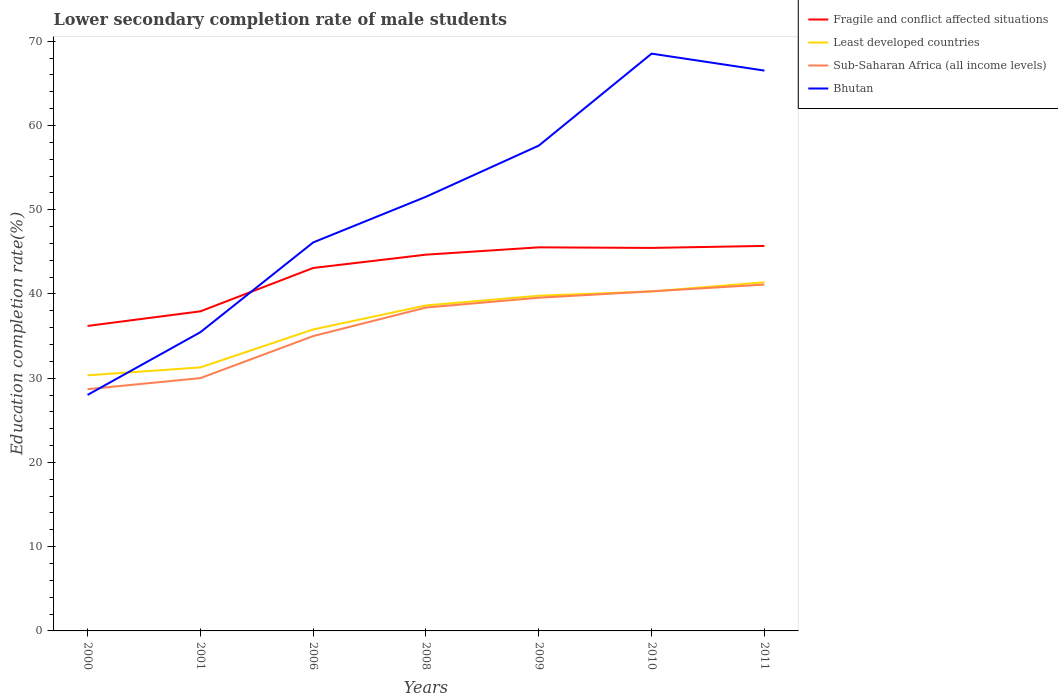Is the number of lines equal to the number of legend labels?
Give a very brief answer. Yes. Across all years, what is the maximum lower secondary completion rate of male students in Fragile and conflict affected situations?
Keep it short and to the point. 36.21. In which year was the lower secondary completion rate of male students in Bhutan maximum?
Provide a short and direct response. 2000. What is the total lower secondary completion rate of male students in Sub-Saharan Africa (all income levels) in the graph?
Provide a succinct answer. -2.72. What is the difference between the highest and the second highest lower secondary completion rate of male students in Bhutan?
Your answer should be very brief. 40.52. What is the difference between the highest and the lowest lower secondary completion rate of male students in Bhutan?
Offer a terse response. 4. Is the lower secondary completion rate of male students in Sub-Saharan Africa (all income levels) strictly greater than the lower secondary completion rate of male students in Fragile and conflict affected situations over the years?
Offer a terse response. Yes. How many lines are there?
Ensure brevity in your answer.  4. How many years are there in the graph?
Give a very brief answer. 7. Does the graph contain grids?
Make the answer very short. No. What is the title of the graph?
Your answer should be compact. Lower secondary completion rate of male students. What is the label or title of the Y-axis?
Offer a very short reply. Education completion rate(%). What is the Education completion rate(%) of Fragile and conflict affected situations in 2000?
Give a very brief answer. 36.21. What is the Education completion rate(%) in Least developed countries in 2000?
Provide a succinct answer. 30.35. What is the Education completion rate(%) of Sub-Saharan Africa (all income levels) in 2000?
Give a very brief answer. 28.7. What is the Education completion rate(%) in Bhutan in 2000?
Offer a terse response. 28.02. What is the Education completion rate(%) of Fragile and conflict affected situations in 2001?
Keep it short and to the point. 37.94. What is the Education completion rate(%) in Least developed countries in 2001?
Give a very brief answer. 31.28. What is the Education completion rate(%) of Sub-Saharan Africa (all income levels) in 2001?
Offer a very short reply. 30.01. What is the Education completion rate(%) of Bhutan in 2001?
Your answer should be compact. 35.46. What is the Education completion rate(%) of Fragile and conflict affected situations in 2006?
Give a very brief answer. 43.09. What is the Education completion rate(%) in Least developed countries in 2006?
Make the answer very short. 35.79. What is the Education completion rate(%) of Sub-Saharan Africa (all income levels) in 2006?
Your answer should be compact. 35. What is the Education completion rate(%) in Bhutan in 2006?
Offer a terse response. 46.12. What is the Education completion rate(%) of Fragile and conflict affected situations in 2008?
Your response must be concise. 44.67. What is the Education completion rate(%) in Least developed countries in 2008?
Make the answer very short. 38.64. What is the Education completion rate(%) in Sub-Saharan Africa (all income levels) in 2008?
Your response must be concise. 38.39. What is the Education completion rate(%) of Bhutan in 2008?
Provide a short and direct response. 51.54. What is the Education completion rate(%) in Fragile and conflict affected situations in 2009?
Offer a terse response. 45.54. What is the Education completion rate(%) of Least developed countries in 2009?
Give a very brief answer. 39.79. What is the Education completion rate(%) of Sub-Saharan Africa (all income levels) in 2009?
Ensure brevity in your answer.  39.55. What is the Education completion rate(%) in Bhutan in 2009?
Give a very brief answer. 57.62. What is the Education completion rate(%) of Fragile and conflict affected situations in 2010?
Keep it short and to the point. 45.47. What is the Education completion rate(%) in Least developed countries in 2010?
Provide a short and direct response. 40.3. What is the Education completion rate(%) of Sub-Saharan Africa (all income levels) in 2010?
Your answer should be compact. 40.32. What is the Education completion rate(%) of Bhutan in 2010?
Provide a short and direct response. 68.53. What is the Education completion rate(%) in Fragile and conflict affected situations in 2011?
Keep it short and to the point. 45.71. What is the Education completion rate(%) of Least developed countries in 2011?
Offer a terse response. 41.39. What is the Education completion rate(%) of Sub-Saharan Africa (all income levels) in 2011?
Provide a short and direct response. 41.12. What is the Education completion rate(%) of Bhutan in 2011?
Offer a very short reply. 66.52. Across all years, what is the maximum Education completion rate(%) of Fragile and conflict affected situations?
Provide a short and direct response. 45.71. Across all years, what is the maximum Education completion rate(%) of Least developed countries?
Your answer should be compact. 41.39. Across all years, what is the maximum Education completion rate(%) of Sub-Saharan Africa (all income levels)?
Provide a short and direct response. 41.12. Across all years, what is the maximum Education completion rate(%) in Bhutan?
Keep it short and to the point. 68.53. Across all years, what is the minimum Education completion rate(%) in Fragile and conflict affected situations?
Give a very brief answer. 36.21. Across all years, what is the minimum Education completion rate(%) of Least developed countries?
Your response must be concise. 30.35. Across all years, what is the minimum Education completion rate(%) of Sub-Saharan Africa (all income levels)?
Offer a very short reply. 28.7. Across all years, what is the minimum Education completion rate(%) of Bhutan?
Offer a terse response. 28.02. What is the total Education completion rate(%) in Fragile and conflict affected situations in the graph?
Ensure brevity in your answer.  298.62. What is the total Education completion rate(%) of Least developed countries in the graph?
Give a very brief answer. 257.55. What is the total Education completion rate(%) of Sub-Saharan Africa (all income levels) in the graph?
Offer a very short reply. 253.1. What is the total Education completion rate(%) of Bhutan in the graph?
Give a very brief answer. 353.82. What is the difference between the Education completion rate(%) of Fragile and conflict affected situations in 2000 and that in 2001?
Give a very brief answer. -1.73. What is the difference between the Education completion rate(%) of Least developed countries in 2000 and that in 2001?
Ensure brevity in your answer.  -0.94. What is the difference between the Education completion rate(%) in Sub-Saharan Africa (all income levels) in 2000 and that in 2001?
Offer a terse response. -1.31. What is the difference between the Education completion rate(%) of Bhutan in 2000 and that in 2001?
Offer a terse response. -7.45. What is the difference between the Education completion rate(%) of Fragile and conflict affected situations in 2000 and that in 2006?
Provide a succinct answer. -6.88. What is the difference between the Education completion rate(%) of Least developed countries in 2000 and that in 2006?
Ensure brevity in your answer.  -5.44. What is the difference between the Education completion rate(%) of Sub-Saharan Africa (all income levels) in 2000 and that in 2006?
Ensure brevity in your answer.  -6.3. What is the difference between the Education completion rate(%) of Bhutan in 2000 and that in 2006?
Give a very brief answer. -18.1. What is the difference between the Education completion rate(%) of Fragile and conflict affected situations in 2000 and that in 2008?
Make the answer very short. -8.46. What is the difference between the Education completion rate(%) of Least developed countries in 2000 and that in 2008?
Offer a very short reply. -8.3. What is the difference between the Education completion rate(%) of Sub-Saharan Africa (all income levels) in 2000 and that in 2008?
Make the answer very short. -9.69. What is the difference between the Education completion rate(%) of Bhutan in 2000 and that in 2008?
Provide a short and direct response. -23.53. What is the difference between the Education completion rate(%) in Fragile and conflict affected situations in 2000 and that in 2009?
Your answer should be very brief. -9.33. What is the difference between the Education completion rate(%) of Least developed countries in 2000 and that in 2009?
Your response must be concise. -9.45. What is the difference between the Education completion rate(%) in Sub-Saharan Africa (all income levels) in 2000 and that in 2009?
Keep it short and to the point. -10.85. What is the difference between the Education completion rate(%) in Bhutan in 2000 and that in 2009?
Offer a terse response. -29.6. What is the difference between the Education completion rate(%) in Fragile and conflict affected situations in 2000 and that in 2010?
Your answer should be compact. -9.26. What is the difference between the Education completion rate(%) of Least developed countries in 2000 and that in 2010?
Make the answer very short. -9.96. What is the difference between the Education completion rate(%) of Sub-Saharan Africa (all income levels) in 2000 and that in 2010?
Provide a short and direct response. -11.62. What is the difference between the Education completion rate(%) of Bhutan in 2000 and that in 2010?
Your answer should be compact. -40.52. What is the difference between the Education completion rate(%) in Fragile and conflict affected situations in 2000 and that in 2011?
Offer a very short reply. -9.5. What is the difference between the Education completion rate(%) of Least developed countries in 2000 and that in 2011?
Offer a terse response. -11.04. What is the difference between the Education completion rate(%) of Sub-Saharan Africa (all income levels) in 2000 and that in 2011?
Your response must be concise. -12.42. What is the difference between the Education completion rate(%) in Bhutan in 2000 and that in 2011?
Provide a succinct answer. -38.5. What is the difference between the Education completion rate(%) in Fragile and conflict affected situations in 2001 and that in 2006?
Your answer should be very brief. -5.15. What is the difference between the Education completion rate(%) of Least developed countries in 2001 and that in 2006?
Offer a very short reply. -4.51. What is the difference between the Education completion rate(%) of Sub-Saharan Africa (all income levels) in 2001 and that in 2006?
Provide a short and direct response. -4.99. What is the difference between the Education completion rate(%) in Bhutan in 2001 and that in 2006?
Your answer should be compact. -10.66. What is the difference between the Education completion rate(%) in Fragile and conflict affected situations in 2001 and that in 2008?
Your response must be concise. -6.73. What is the difference between the Education completion rate(%) of Least developed countries in 2001 and that in 2008?
Your response must be concise. -7.36. What is the difference between the Education completion rate(%) in Sub-Saharan Africa (all income levels) in 2001 and that in 2008?
Give a very brief answer. -8.38. What is the difference between the Education completion rate(%) of Bhutan in 2001 and that in 2008?
Keep it short and to the point. -16.08. What is the difference between the Education completion rate(%) of Fragile and conflict affected situations in 2001 and that in 2009?
Your answer should be very brief. -7.6. What is the difference between the Education completion rate(%) in Least developed countries in 2001 and that in 2009?
Your answer should be very brief. -8.51. What is the difference between the Education completion rate(%) in Sub-Saharan Africa (all income levels) in 2001 and that in 2009?
Your answer should be compact. -9.54. What is the difference between the Education completion rate(%) of Bhutan in 2001 and that in 2009?
Provide a short and direct response. -22.15. What is the difference between the Education completion rate(%) in Fragile and conflict affected situations in 2001 and that in 2010?
Give a very brief answer. -7.53. What is the difference between the Education completion rate(%) in Least developed countries in 2001 and that in 2010?
Offer a very short reply. -9.02. What is the difference between the Education completion rate(%) of Sub-Saharan Africa (all income levels) in 2001 and that in 2010?
Offer a terse response. -10.3. What is the difference between the Education completion rate(%) of Bhutan in 2001 and that in 2010?
Offer a terse response. -33.07. What is the difference between the Education completion rate(%) of Fragile and conflict affected situations in 2001 and that in 2011?
Your answer should be compact. -7.77. What is the difference between the Education completion rate(%) of Least developed countries in 2001 and that in 2011?
Offer a very short reply. -10.1. What is the difference between the Education completion rate(%) in Sub-Saharan Africa (all income levels) in 2001 and that in 2011?
Ensure brevity in your answer.  -11.1. What is the difference between the Education completion rate(%) of Bhutan in 2001 and that in 2011?
Provide a succinct answer. -31.06. What is the difference between the Education completion rate(%) of Fragile and conflict affected situations in 2006 and that in 2008?
Your answer should be compact. -1.58. What is the difference between the Education completion rate(%) of Least developed countries in 2006 and that in 2008?
Your answer should be compact. -2.85. What is the difference between the Education completion rate(%) in Sub-Saharan Africa (all income levels) in 2006 and that in 2008?
Give a very brief answer. -3.39. What is the difference between the Education completion rate(%) of Bhutan in 2006 and that in 2008?
Provide a succinct answer. -5.42. What is the difference between the Education completion rate(%) of Fragile and conflict affected situations in 2006 and that in 2009?
Your answer should be compact. -2.45. What is the difference between the Education completion rate(%) of Least developed countries in 2006 and that in 2009?
Your answer should be compact. -4. What is the difference between the Education completion rate(%) of Sub-Saharan Africa (all income levels) in 2006 and that in 2009?
Provide a succinct answer. -4.55. What is the difference between the Education completion rate(%) of Bhutan in 2006 and that in 2009?
Offer a terse response. -11.49. What is the difference between the Education completion rate(%) of Fragile and conflict affected situations in 2006 and that in 2010?
Your answer should be very brief. -2.38. What is the difference between the Education completion rate(%) of Least developed countries in 2006 and that in 2010?
Offer a terse response. -4.51. What is the difference between the Education completion rate(%) of Sub-Saharan Africa (all income levels) in 2006 and that in 2010?
Give a very brief answer. -5.31. What is the difference between the Education completion rate(%) of Bhutan in 2006 and that in 2010?
Give a very brief answer. -22.41. What is the difference between the Education completion rate(%) of Fragile and conflict affected situations in 2006 and that in 2011?
Offer a very short reply. -2.62. What is the difference between the Education completion rate(%) of Least developed countries in 2006 and that in 2011?
Ensure brevity in your answer.  -5.6. What is the difference between the Education completion rate(%) of Sub-Saharan Africa (all income levels) in 2006 and that in 2011?
Offer a terse response. -6.11. What is the difference between the Education completion rate(%) in Bhutan in 2006 and that in 2011?
Offer a terse response. -20.4. What is the difference between the Education completion rate(%) of Fragile and conflict affected situations in 2008 and that in 2009?
Offer a terse response. -0.87. What is the difference between the Education completion rate(%) of Least developed countries in 2008 and that in 2009?
Your response must be concise. -1.15. What is the difference between the Education completion rate(%) of Sub-Saharan Africa (all income levels) in 2008 and that in 2009?
Your answer should be compact. -1.16. What is the difference between the Education completion rate(%) in Bhutan in 2008 and that in 2009?
Offer a terse response. -6.07. What is the difference between the Education completion rate(%) of Fragile and conflict affected situations in 2008 and that in 2010?
Your answer should be compact. -0.8. What is the difference between the Education completion rate(%) of Least developed countries in 2008 and that in 2010?
Offer a very short reply. -1.66. What is the difference between the Education completion rate(%) in Sub-Saharan Africa (all income levels) in 2008 and that in 2010?
Offer a terse response. -1.92. What is the difference between the Education completion rate(%) of Bhutan in 2008 and that in 2010?
Provide a short and direct response. -16.99. What is the difference between the Education completion rate(%) in Fragile and conflict affected situations in 2008 and that in 2011?
Your answer should be compact. -1.04. What is the difference between the Education completion rate(%) in Least developed countries in 2008 and that in 2011?
Give a very brief answer. -2.75. What is the difference between the Education completion rate(%) in Sub-Saharan Africa (all income levels) in 2008 and that in 2011?
Your answer should be compact. -2.72. What is the difference between the Education completion rate(%) of Bhutan in 2008 and that in 2011?
Make the answer very short. -14.98. What is the difference between the Education completion rate(%) of Fragile and conflict affected situations in 2009 and that in 2010?
Keep it short and to the point. 0.07. What is the difference between the Education completion rate(%) of Least developed countries in 2009 and that in 2010?
Give a very brief answer. -0.51. What is the difference between the Education completion rate(%) of Sub-Saharan Africa (all income levels) in 2009 and that in 2010?
Provide a short and direct response. -0.76. What is the difference between the Education completion rate(%) in Bhutan in 2009 and that in 2010?
Give a very brief answer. -10.92. What is the difference between the Education completion rate(%) in Fragile and conflict affected situations in 2009 and that in 2011?
Your answer should be very brief. -0.17. What is the difference between the Education completion rate(%) of Least developed countries in 2009 and that in 2011?
Provide a succinct answer. -1.59. What is the difference between the Education completion rate(%) of Sub-Saharan Africa (all income levels) in 2009 and that in 2011?
Provide a succinct answer. -1.56. What is the difference between the Education completion rate(%) in Bhutan in 2009 and that in 2011?
Provide a succinct answer. -8.91. What is the difference between the Education completion rate(%) in Fragile and conflict affected situations in 2010 and that in 2011?
Offer a terse response. -0.24. What is the difference between the Education completion rate(%) in Least developed countries in 2010 and that in 2011?
Provide a succinct answer. -1.09. What is the difference between the Education completion rate(%) in Sub-Saharan Africa (all income levels) in 2010 and that in 2011?
Your answer should be very brief. -0.8. What is the difference between the Education completion rate(%) in Bhutan in 2010 and that in 2011?
Offer a very short reply. 2.01. What is the difference between the Education completion rate(%) of Fragile and conflict affected situations in 2000 and the Education completion rate(%) of Least developed countries in 2001?
Offer a very short reply. 4.92. What is the difference between the Education completion rate(%) of Fragile and conflict affected situations in 2000 and the Education completion rate(%) of Sub-Saharan Africa (all income levels) in 2001?
Your answer should be very brief. 6.2. What is the difference between the Education completion rate(%) of Fragile and conflict affected situations in 2000 and the Education completion rate(%) of Bhutan in 2001?
Ensure brevity in your answer.  0.74. What is the difference between the Education completion rate(%) in Least developed countries in 2000 and the Education completion rate(%) in Sub-Saharan Africa (all income levels) in 2001?
Keep it short and to the point. 0.33. What is the difference between the Education completion rate(%) of Least developed countries in 2000 and the Education completion rate(%) of Bhutan in 2001?
Your response must be concise. -5.12. What is the difference between the Education completion rate(%) of Sub-Saharan Africa (all income levels) in 2000 and the Education completion rate(%) of Bhutan in 2001?
Make the answer very short. -6.76. What is the difference between the Education completion rate(%) of Fragile and conflict affected situations in 2000 and the Education completion rate(%) of Least developed countries in 2006?
Keep it short and to the point. 0.42. What is the difference between the Education completion rate(%) in Fragile and conflict affected situations in 2000 and the Education completion rate(%) in Sub-Saharan Africa (all income levels) in 2006?
Give a very brief answer. 1.2. What is the difference between the Education completion rate(%) in Fragile and conflict affected situations in 2000 and the Education completion rate(%) in Bhutan in 2006?
Your answer should be compact. -9.91. What is the difference between the Education completion rate(%) in Least developed countries in 2000 and the Education completion rate(%) in Sub-Saharan Africa (all income levels) in 2006?
Offer a terse response. -4.66. What is the difference between the Education completion rate(%) of Least developed countries in 2000 and the Education completion rate(%) of Bhutan in 2006?
Offer a very short reply. -15.78. What is the difference between the Education completion rate(%) in Sub-Saharan Africa (all income levels) in 2000 and the Education completion rate(%) in Bhutan in 2006?
Provide a short and direct response. -17.42. What is the difference between the Education completion rate(%) of Fragile and conflict affected situations in 2000 and the Education completion rate(%) of Least developed countries in 2008?
Your response must be concise. -2.44. What is the difference between the Education completion rate(%) in Fragile and conflict affected situations in 2000 and the Education completion rate(%) in Sub-Saharan Africa (all income levels) in 2008?
Make the answer very short. -2.19. What is the difference between the Education completion rate(%) of Fragile and conflict affected situations in 2000 and the Education completion rate(%) of Bhutan in 2008?
Your answer should be compact. -15.34. What is the difference between the Education completion rate(%) of Least developed countries in 2000 and the Education completion rate(%) of Sub-Saharan Africa (all income levels) in 2008?
Your answer should be very brief. -8.05. What is the difference between the Education completion rate(%) in Least developed countries in 2000 and the Education completion rate(%) in Bhutan in 2008?
Offer a very short reply. -21.2. What is the difference between the Education completion rate(%) of Sub-Saharan Africa (all income levels) in 2000 and the Education completion rate(%) of Bhutan in 2008?
Provide a short and direct response. -22.84. What is the difference between the Education completion rate(%) of Fragile and conflict affected situations in 2000 and the Education completion rate(%) of Least developed countries in 2009?
Ensure brevity in your answer.  -3.59. What is the difference between the Education completion rate(%) of Fragile and conflict affected situations in 2000 and the Education completion rate(%) of Sub-Saharan Africa (all income levels) in 2009?
Make the answer very short. -3.35. What is the difference between the Education completion rate(%) in Fragile and conflict affected situations in 2000 and the Education completion rate(%) in Bhutan in 2009?
Your answer should be very brief. -21.41. What is the difference between the Education completion rate(%) in Least developed countries in 2000 and the Education completion rate(%) in Sub-Saharan Africa (all income levels) in 2009?
Provide a short and direct response. -9.21. What is the difference between the Education completion rate(%) of Least developed countries in 2000 and the Education completion rate(%) of Bhutan in 2009?
Offer a very short reply. -27.27. What is the difference between the Education completion rate(%) of Sub-Saharan Africa (all income levels) in 2000 and the Education completion rate(%) of Bhutan in 2009?
Your response must be concise. -28.92. What is the difference between the Education completion rate(%) in Fragile and conflict affected situations in 2000 and the Education completion rate(%) in Least developed countries in 2010?
Offer a terse response. -4.09. What is the difference between the Education completion rate(%) of Fragile and conflict affected situations in 2000 and the Education completion rate(%) of Sub-Saharan Africa (all income levels) in 2010?
Your answer should be very brief. -4.11. What is the difference between the Education completion rate(%) of Fragile and conflict affected situations in 2000 and the Education completion rate(%) of Bhutan in 2010?
Provide a short and direct response. -32.33. What is the difference between the Education completion rate(%) of Least developed countries in 2000 and the Education completion rate(%) of Sub-Saharan Africa (all income levels) in 2010?
Offer a terse response. -9.97. What is the difference between the Education completion rate(%) of Least developed countries in 2000 and the Education completion rate(%) of Bhutan in 2010?
Offer a terse response. -38.19. What is the difference between the Education completion rate(%) of Sub-Saharan Africa (all income levels) in 2000 and the Education completion rate(%) of Bhutan in 2010?
Offer a very short reply. -39.83. What is the difference between the Education completion rate(%) in Fragile and conflict affected situations in 2000 and the Education completion rate(%) in Least developed countries in 2011?
Your answer should be compact. -5.18. What is the difference between the Education completion rate(%) of Fragile and conflict affected situations in 2000 and the Education completion rate(%) of Sub-Saharan Africa (all income levels) in 2011?
Give a very brief answer. -4.91. What is the difference between the Education completion rate(%) in Fragile and conflict affected situations in 2000 and the Education completion rate(%) in Bhutan in 2011?
Your response must be concise. -30.32. What is the difference between the Education completion rate(%) in Least developed countries in 2000 and the Education completion rate(%) in Sub-Saharan Africa (all income levels) in 2011?
Provide a succinct answer. -10.77. What is the difference between the Education completion rate(%) in Least developed countries in 2000 and the Education completion rate(%) in Bhutan in 2011?
Offer a very short reply. -36.18. What is the difference between the Education completion rate(%) of Sub-Saharan Africa (all income levels) in 2000 and the Education completion rate(%) of Bhutan in 2011?
Offer a terse response. -37.82. What is the difference between the Education completion rate(%) in Fragile and conflict affected situations in 2001 and the Education completion rate(%) in Least developed countries in 2006?
Ensure brevity in your answer.  2.15. What is the difference between the Education completion rate(%) in Fragile and conflict affected situations in 2001 and the Education completion rate(%) in Sub-Saharan Africa (all income levels) in 2006?
Your answer should be very brief. 2.94. What is the difference between the Education completion rate(%) in Fragile and conflict affected situations in 2001 and the Education completion rate(%) in Bhutan in 2006?
Provide a short and direct response. -8.18. What is the difference between the Education completion rate(%) of Least developed countries in 2001 and the Education completion rate(%) of Sub-Saharan Africa (all income levels) in 2006?
Offer a terse response. -3.72. What is the difference between the Education completion rate(%) of Least developed countries in 2001 and the Education completion rate(%) of Bhutan in 2006?
Keep it short and to the point. -14.84. What is the difference between the Education completion rate(%) in Sub-Saharan Africa (all income levels) in 2001 and the Education completion rate(%) in Bhutan in 2006?
Give a very brief answer. -16.11. What is the difference between the Education completion rate(%) of Fragile and conflict affected situations in 2001 and the Education completion rate(%) of Least developed countries in 2008?
Ensure brevity in your answer.  -0.7. What is the difference between the Education completion rate(%) of Fragile and conflict affected situations in 2001 and the Education completion rate(%) of Sub-Saharan Africa (all income levels) in 2008?
Give a very brief answer. -0.45. What is the difference between the Education completion rate(%) in Fragile and conflict affected situations in 2001 and the Education completion rate(%) in Bhutan in 2008?
Your answer should be compact. -13.6. What is the difference between the Education completion rate(%) in Least developed countries in 2001 and the Education completion rate(%) in Sub-Saharan Africa (all income levels) in 2008?
Offer a very short reply. -7.11. What is the difference between the Education completion rate(%) of Least developed countries in 2001 and the Education completion rate(%) of Bhutan in 2008?
Offer a very short reply. -20.26. What is the difference between the Education completion rate(%) in Sub-Saharan Africa (all income levels) in 2001 and the Education completion rate(%) in Bhutan in 2008?
Ensure brevity in your answer.  -21.53. What is the difference between the Education completion rate(%) in Fragile and conflict affected situations in 2001 and the Education completion rate(%) in Least developed countries in 2009?
Your response must be concise. -1.85. What is the difference between the Education completion rate(%) in Fragile and conflict affected situations in 2001 and the Education completion rate(%) in Sub-Saharan Africa (all income levels) in 2009?
Make the answer very short. -1.61. What is the difference between the Education completion rate(%) of Fragile and conflict affected situations in 2001 and the Education completion rate(%) of Bhutan in 2009?
Provide a short and direct response. -19.68. What is the difference between the Education completion rate(%) of Least developed countries in 2001 and the Education completion rate(%) of Sub-Saharan Africa (all income levels) in 2009?
Provide a succinct answer. -8.27. What is the difference between the Education completion rate(%) of Least developed countries in 2001 and the Education completion rate(%) of Bhutan in 2009?
Provide a succinct answer. -26.33. What is the difference between the Education completion rate(%) in Sub-Saharan Africa (all income levels) in 2001 and the Education completion rate(%) in Bhutan in 2009?
Offer a terse response. -27.6. What is the difference between the Education completion rate(%) in Fragile and conflict affected situations in 2001 and the Education completion rate(%) in Least developed countries in 2010?
Provide a succinct answer. -2.36. What is the difference between the Education completion rate(%) of Fragile and conflict affected situations in 2001 and the Education completion rate(%) of Sub-Saharan Africa (all income levels) in 2010?
Your answer should be very brief. -2.38. What is the difference between the Education completion rate(%) of Fragile and conflict affected situations in 2001 and the Education completion rate(%) of Bhutan in 2010?
Your answer should be very brief. -30.59. What is the difference between the Education completion rate(%) in Least developed countries in 2001 and the Education completion rate(%) in Sub-Saharan Africa (all income levels) in 2010?
Offer a very short reply. -9.03. What is the difference between the Education completion rate(%) of Least developed countries in 2001 and the Education completion rate(%) of Bhutan in 2010?
Ensure brevity in your answer.  -37.25. What is the difference between the Education completion rate(%) in Sub-Saharan Africa (all income levels) in 2001 and the Education completion rate(%) in Bhutan in 2010?
Ensure brevity in your answer.  -38.52. What is the difference between the Education completion rate(%) of Fragile and conflict affected situations in 2001 and the Education completion rate(%) of Least developed countries in 2011?
Your answer should be very brief. -3.45. What is the difference between the Education completion rate(%) of Fragile and conflict affected situations in 2001 and the Education completion rate(%) of Sub-Saharan Africa (all income levels) in 2011?
Your answer should be compact. -3.18. What is the difference between the Education completion rate(%) of Fragile and conflict affected situations in 2001 and the Education completion rate(%) of Bhutan in 2011?
Give a very brief answer. -28.58. What is the difference between the Education completion rate(%) of Least developed countries in 2001 and the Education completion rate(%) of Sub-Saharan Africa (all income levels) in 2011?
Your answer should be compact. -9.83. What is the difference between the Education completion rate(%) of Least developed countries in 2001 and the Education completion rate(%) of Bhutan in 2011?
Your answer should be very brief. -35.24. What is the difference between the Education completion rate(%) in Sub-Saharan Africa (all income levels) in 2001 and the Education completion rate(%) in Bhutan in 2011?
Provide a succinct answer. -36.51. What is the difference between the Education completion rate(%) in Fragile and conflict affected situations in 2006 and the Education completion rate(%) in Least developed countries in 2008?
Provide a short and direct response. 4.45. What is the difference between the Education completion rate(%) in Fragile and conflict affected situations in 2006 and the Education completion rate(%) in Sub-Saharan Africa (all income levels) in 2008?
Your answer should be very brief. 4.7. What is the difference between the Education completion rate(%) in Fragile and conflict affected situations in 2006 and the Education completion rate(%) in Bhutan in 2008?
Your response must be concise. -8.46. What is the difference between the Education completion rate(%) in Least developed countries in 2006 and the Education completion rate(%) in Sub-Saharan Africa (all income levels) in 2008?
Your answer should be very brief. -2.6. What is the difference between the Education completion rate(%) of Least developed countries in 2006 and the Education completion rate(%) of Bhutan in 2008?
Give a very brief answer. -15.75. What is the difference between the Education completion rate(%) in Sub-Saharan Africa (all income levels) in 2006 and the Education completion rate(%) in Bhutan in 2008?
Provide a succinct answer. -16.54. What is the difference between the Education completion rate(%) in Fragile and conflict affected situations in 2006 and the Education completion rate(%) in Least developed countries in 2009?
Keep it short and to the point. 3.29. What is the difference between the Education completion rate(%) of Fragile and conflict affected situations in 2006 and the Education completion rate(%) of Sub-Saharan Africa (all income levels) in 2009?
Provide a succinct answer. 3.53. What is the difference between the Education completion rate(%) in Fragile and conflict affected situations in 2006 and the Education completion rate(%) in Bhutan in 2009?
Your answer should be very brief. -14.53. What is the difference between the Education completion rate(%) of Least developed countries in 2006 and the Education completion rate(%) of Sub-Saharan Africa (all income levels) in 2009?
Offer a terse response. -3.76. What is the difference between the Education completion rate(%) in Least developed countries in 2006 and the Education completion rate(%) in Bhutan in 2009?
Provide a short and direct response. -21.83. What is the difference between the Education completion rate(%) of Sub-Saharan Africa (all income levels) in 2006 and the Education completion rate(%) of Bhutan in 2009?
Make the answer very short. -22.61. What is the difference between the Education completion rate(%) of Fragile and conflict affected situations in 2006 and the Education completion rate(%) of Least developed countries in 2010?
Offer a very short reply. 2.79. What is the difference between the Education completion rate(%) of Fragile and conflict affected situations in 2006 and the Education completion rate(%) of Sub-Saharan Africa (all income levels) in 2010?
Offer a terse response. 2.77. What is the difference between the Education completion rate(%) in Fragile and conflict affected situations in 2006 and the Education completion rate(%) in Bhutan in 2010?
Give a very brief answer. -25.45. What is the difference between the Education completion rate(%) in Least developed countries in 2006 and the Education completion rate(%) in Sub-Saharan Africa (all income levels) in 2010?
Offer a very short reply. -4.53. What is the difference between the Education completion rate(%) in Least developed countries in 2006 and the Education completion rate(%) in Bhutan in 2010?
Provide a short and direct response. -32.74. What is the difference between the Education completion rate(%) of Sub-Saharan Africa (all income levels) in 2006 and the Education completion rate(%) of Bhutan in 2010?
Offer a terse response. -33.53. What is the difference between the Education completion rate(%) in Fragile and conflict affected situations in 2006 and the Education completion rate(%) in Least developed countries in 2011?
Offer a terse response. 1.7. What is the difference between the Education completion rate(%) in Fragile and conflict affected situations in 2006 and the Education completion rate(%) in Sub-Saharan Africa (all income levels) in 2011?
Your answer should be compact. 1.97. What is the difference between the Education completion rate(%) in Fragile and conflict affected situations in 2006 and the Education completion rate(%) in Bhutan in 2011?
Make the answer very short. -23.43. What is the difference between the Education completion rate(%) of Least developed countries in 2006 and the Education completion rate(%) of Sub-Saharan Africa (all income levels) in 2011?
Offer a very short reply. -5.33. What is the difference between the Education completion rate(%) in Least developed countries in 2006 and the Education completion rate(%) in Bhutan in 2011?
Ensure brevity in your answer.  -30.73. What is the difference between the Education completion rate(%) of Sub-Saharan Africa (all income levels) in 2006 and the Education completion rate(%) of Bhutan in 2011?
Your response must be concise. -31.52. What is the difference between the Education completion rate(%) of Fragile and conflict affected situations in 2008 and the Education completion rate(%) of Least developed countries in 2009?
Your response must be concise. 4.87. What is the difference between the Education completion rate(%) in Fragile and conflict affected situations in 2008 and the Education completion rate(%) in Sub-Saharan Africa (all income levels) in 2009?
Provide a succinct answer. 5.11. What is the difference between the Education completion rate(%) in Fragile and conflict affected situations in 2008 and the Education completion rate(%) in Bhutan in 2009?
Your response must be concise. -12.95. What is the difference between the Education completion rate(%) of Least developed countries in 2008 and the Education completion rate(%) of Sub-Saharan Africa (all income levels) in 2009?
Give a very brief answer. -0.91. What is the difference between the Education completion rate(%) in Least developed countries in 2008 and the Education completion rate(%) in Bhutan in 2009?
Offer a very short reply. -18.97. What is the difference between the Education completion rate(%) of Sub-Saharan Africa (all income levels) in 2008 and the Education completion rate(%) of Bhutan in 2009?
Provide a short and direct response. -19.22. What is the difference between the Education completion rate(%) in Fragile and conflict affected situations in 2008 and the Education completion rate(%) in Least developed countries in 2010?
Keep it short and to the point. 4.37. What is the difference between the Education completion rate(%) of Fragile and conflict affected situations in 2008 and the Education completion rate(%) of Sub-Saharan Africa (all income levels) in 2010?
Offer a terse response. 4.35. What is the difference between the Education completion rate(%) in Fragile and conflict affected situations in 2008 and the Education completion rate(%) in Bhutan in 2010?
Offer a terse response. -23.87. What is the difference between the Education completion rate(%) in Least developed countries in 2008 and the Education completion rate(%) in Sub-Saharan Africa (all income levels) in 2010?
Ensure brevity in your answer.  -1.67. What is the difference between the Education completion rate(%) in Least developed countries in 2008 and the Education completion rate(%) in Bhutan in 2010?
Your answer should be very brief. -29.89. What is the difference between the Education completion rate(%) in Sub-Saharan Africa (all income levels) in 2008 and the Education completion rate(%) in Bhutan in 2010?
Your response must be concise. -30.14. What is the difference between the Education completion rate(%) in Fragile and conflict affected situations in 2008 and the Education completion rate(%) in Least developed countries in 2011?
Make the answer very short. 3.28. What is the difference between the Education completion rate(%) of Fragile and conflict affected situations in 2008 and the Education completion rate(%) of Sub-Saharan Africa (all income levels) in 2011?
Make the answer very short. 3.55. What is the difference between the Education completion rate(%) of Fragile and conflict affected situations in 2008 and the Education completion rate(%) of Bhutan in 2011?
Your answer should be compact. -21.85. What is the difference between the Education completion rate(%) in Least developed countries in 2008 and the Education completion rate(%) in Sub-Saharan Africa (all income levels) in 2011?
Ensure brevity in your answer.  -2.47. What is the difference between the Education completion rate(%) of Least developed countries in 2008 and the Education completion rate(%) of Bhutan in 2011?
Provide a succinct answer. -27.88. What is the difference between the Education completion rate(%) of Sub-Saharan Africa (all income levels) in 2008 and the Education completion rate(%) of Bhutan in 2011?
Your answer should be compact. -28.13. What is the difference between the Education completion rate(%) of Fragile and conflict affected situations in 2009 and the Education completion rate(%) of Least developed countries in 2010?
Your answer should be compact. 5.24. What is the difference between the Education completion rate(%) of Fragile and conflict affected situations in 2009 and the Education completion rate(%) of Sub-Saharan Africa (all income levels) in 2010?
Give a very brief answer. 5.22. What is the difference between the Education completion rate(%) in Fragile and conflict affected situations in 2009 and the Education completion rate(%) in Bhutan in 2010?
Your answer should be very brief. -23. What is the difference between the Education completion rate(%) of Least developed countries in 2009 and the Education completion rate(%) of Sub-Saharan Africa (all income levels) in 2010?
Offer a terse response. -0.52. What is the difference between the Education completion rate(%) of Least developed countries in 2009 and the Education completion rate(%) of Bhutan in 2010?
Your answer should be very brief. -28.74. What is the difference between the Education completion rate(%) of Sub-Saharan Africa (all income levels) in 2009 and the Education completion rate(%) of Bhutan in 2010?
Your answer should be compact. -28.98. What is the difference between the Education completion rate(%) in Fragile and conflict affected situations in 2009 and the Education completion rate(%) in Least developed countries in 2011?
Your answer should be compact. 4.15. What is the difference between the Education completion rate(%) of Fragile and conflict affected situations in 2009 and the Education completion rate(%) of Sub-Saharan Africa (all income levels) in 2011?
Your response must be concise. 4.42. What is the difference between the Education completion rate(%) of Fragile and conflict affected situations in 2009 and the Education completion rate(%) of Bhutan in 2011?
Your response must be concise. -20.98. What is the difference between the Education completion rate(%) of Least developed countries in 2009 and the Education completion rate(%) of Sub-Saharan Africa (all income levels) in 2011?
Ensure brevity in your answer.  -1.32. What is the difference between the Education completion rate(%) in Least developed countries in 2009 and the Education completion rate(%) in Bhutan in 2011?
Ensure brevity in your answer.  -26.73. What is the difference between the Education completion rate(%) of Sub-Saharan Africa (all income levels) in 2009 and the Education completion rate(%) of Bhutan in 2011?
Your answer should be compact. -26.97. What is the difference between the Education completion rate(%) of Fragile and conflict affected situations in 2010 and the Education completion rate(%) of Least developed countries in 2011?
Give a very brief answer. 4.08. What is the difference between the Education completion rate(%) in Fragile and conflict affected situations in 2010 and the Education completion rate(%) in Sub-Saharan Africa (all income levels) in 2011?
Keep it short and to the point. 4.35. What is the difference between the Education completion rate(%) of Fragile and conflict affected situations in 2010 and the Education completion rate(%) of Bhutan in 2011?
Your answer should be compact. -21.05. What is the difference between the Education completion rate(%) of Least developed countries in 2010 and the Education completion rate(%) of Sub-Saharan Africa (all income levels) in 2011?
Provide a succinct answer. -0.82. What is the difference between the Education completion rate(%) of Least developed countries in 2010 and the Education completion rate(%) of Bhutan in 2011?
Offer a terse response. -26.22. What is the difference between the Education completion rate(%) in Sub-Saharan Africa (all income levels) in 2010 and the Education completion rate(%) in Bhutan in 2011?
Give a very brief answer. -26.21. What is the average Education completion rate(%) of Fragile and conflict affected situations per year?
Keep it short and to the point. 42.66. What is the average Education completion rate(%) of Least developed countries per year?
Your answer should be compact. 36.79. What is the average Education completion rate(%) in Sub-Saharan Africa (all income levels) per year?
Provide a short and direct response. 36.16. What is the average Education completion rate(%) in Bhutan per year?
Give a very brief answer. 50.55. In the year 2000, what is the difference between the Education completion rate(%) in Fragile and conflict affected situations and Education completion rate(%) in Least developed countries?
Your answer should be compact. 5.86. In the year 2000, what is the difference between the Education completion rate(%) of Fragile and conflict affected situations and Education completion rate(%) of Sub-Saharan Africa (all income levels)?
Offer a very short reply. 7.51. In the year 2000, what is the difference between the Education completion rate(%) of Fragile and conflict affected situations and Education completion rate(%) of Bhutan?
Your response must be concise. 8.19. In the year 2000, what is the difference between the Education completion rate(%) of Least developed countries and Education completion rate(%) of Sub-Saharan Africa (all income levels)?
Provide a succinct answer. 1.65. In the year 2000, what is the difference between the Education completion rate(%) of Least developed countries and Education completion rate(%) of Bhutan?
Your answer should be very brief. 2.33. In the year 2000, what is the difference between the Education completion rate(%) of Sub-Saharan Africa (all income levels) and Education completion rate(%) of Bhutan?
Give a very brief answer. 0.68. In the year 2001, what is the difference between the Education completion rate(%) in Fragile and conflict affected situations and Education completion rate(%) in Least developed countries?
Your response must be concise. 6.66. In the year 2001, what is the difference between the Education completion rate(%) in Fragile and conflict affected situations and Education completion rate(%) in Sub-Saharan Africa (all income levels)?
Make the answer very short. 7.93. In the year 2001, what is the difference between the Education completion rate(%) of Fragile and conflict affected situations and Education completion rate(%) of Bhutan?
Your answer should be very brief. 2.48. In the year 2001, what is the difference between the Education completion rate(%) in Least developed countries and Education completion rate(%) in Sub-Saharan Africa (all income levels)?
Provide a short and direct response. 1.27. In the year 2001, what is the difference between the Education completion rate(%) in Least developed countries and Education completion rate(%) in Bhutan?
Ensure brevity in your answer.  -4.18. In the year 2001, what is the difference between the Education completion rate(%) of Sub-Saharan Africa (all income levels) and Education completion rate(%) of Bhutan?
Your answer should be very brief. -5.45. In the year 2006, what is the difference between the Education completion rate(%) of Fragile and conflict affected situations and Education completion rate(%) of Least developed countries?
Your response must be concise. 7.3. In the year 2006, what is the difference between the Education completion rate(%) in Fragile and conflict affected situations and Education completion rate(%) in Sub-Saharan Africa (all income levels)?
Provide a short and direct response. 8.09. In the year 2006, what is the difference between the Education completion rate(%) in Fragile and conflict affected situations and Education completion rate(%) in Bhutan?
Your answer should be very brief. -3.03. In the year 2006, what is the difference between the Education completion rate(%) of Least developed countries and Education completion rate(%) of Sub-Saharan Africa (all income levels)?
Your answer should be very brief. 0.79. In the year 2006, what is the difference between the Education completion rate(%) of Least developed countries and Education completion rate(%) of Bhutan?
Your answer should be compact. -10.33. In the year 2006, what is the difference between the Education completion rate(%) of Sub-Saharan Africa (all income levels) and Education completion rate(%) of Bhutan?
Ensure brevity in your answer.  -11.12. In the year 2008, what is the difference between the Education completion rate(%) of Fragile and conflict affected situations and Education completion rate(%) of Least developed countries?
Make the answer very short. 6.03. In the year 2008, what is the difference between the Education completion rate(%) in Fragile and conflict affected situations and Education completion rate(%) in Sub-Saharan Africa (all income levels)?
Ensure brevity in your answer.  6.28. In the year 2008, what is the difference between the Education completion rate(%) of Fragile and conflict affected situations and Education completion rate(%) of Bhutan?
Your answer should be compact. -6.87. In the year 2008, what is the difference between the Education completion rate(%) of Least developed countries and Education completion rate(%) of Sub-Saharan Africa (all income levels)?
Your response must be concise. 0.25. In the year 2008, what is the difference between the Education completion rate(%) in Least developed countries and Education completion rate(%) in Bhutan?
Offer a terse response. -12.9. In the year 2008, what is the difference between the Education completion rate(%) in Sub-Saharan Africa (all income levels) and Education completion rate(%) in Bhutan?
Make the answer very short. -13.15. In the year 2009, what is the difference between the Education completion rate(%) in Fragile and conflict affected situations and Education completion rate(%) in Least developed countries?
Offer a very short reply. 5.74. In the year 2009, what is the difference between the Education completion rate(%) in Fragile and conflict affected situations and Education completion rate(%) in Sub-Saharan Africa (all income levels)?
Your response must be concise. 5.98. In the year 2009, what is the difference between the Education completion rate(%) of Fragile and conflict affected situations and Education completion rate(%) of Bhutan?
Offer a terse response. -12.08. In the year 2009, what is the difference between the Education completion rate(%) of Least developed countries and Education completion rate(%) of Sub-Saharan Africa (all income levels)?
Give a very brief answer. 0.24. In the year 2009, what is the difference between the Education completion rate(%) of Least developed countries and Education completion rate(%) of Bhutan?
Ensure brevity in your answer.  -17.82. In the year 2009, what is the difference between the Education completion rate(%) in Sub-Saharan Africa (all income levels) and Education completion rate(%) in Bhutan?
Your answer should be very brief. -18.06. In the year 2010, what is the difference between the Education completion rate(%) of Fragile and conflict affected situations and Education completion rate(%) of Least developed countries?
Ensure brevity in your answer.  5.17. In the year 2010, what is the difference between the Education completion rate(%) in Fragile and conflict affected situations and Education completion rate(%) in Sub-Saharan Africa (all income levels)?
Keep it short and to the point. 5.15. In the year 2010, what is the difference between the Education completion rate(%) in Fragile and conflict affected situations and Education completion rate(%) in Bhutan?
Give a very brief answer. -23.07. In the year 2010, what is the difference between the Education completion rate(%) of Least developed countries and Education completion rate(%) of Sub-Saharan Africa (all income levels)?
Provide a succinct answer. -0.01. In the year 2010, what is the difference between the Education completion rate(%) in Least developed countries and Education completion rate(%) in Bhutan?
Your answer should be compact. -28.23. In the year 2010, what is the difference between the Education completion rate(%) of Sub-Saharan Africa (all income levels) and Education completion rate(%) of Bhutan?
Keep it short and to the point. -28.22. In the year 2011, what is the difference between the Education completion rate(%) of Fragile and conflict affected situations and Education completion rate(%) of Least developed countries?
Your answer should be compact. 4.32. In the year 2011, what is the difference between the Education completion rate(%) in Fragile and conflict affected situations and Education completion rate(%) in Sub-Saharan Africa (all income levels)?
Offer a very short reply. 4.59. In the year 2011, what is the difference between the Education completion rate(%) of Fragile and conflict affected situations and Education completion rate(%) of Bhutan?
Your answer should be compact. -20.82. In the year 2011, what is the difference between the Education completion rate(%) in Least developed countries and Education completion rate(%) in Sub-Saharan Africa (all income levels)?
Your answer should be very brief. 0.27. In the year 2011, what is the difference between the Education completion rate(%) in Least developed countries and Education completion rate(%) in Bhutan?
Offer a very short reply. -25.13. In the year 2011, what is the difference between the Education completion rate(%) in Sub-Saharan Africa (all income levels) and Education completion rate(%) in Bhutan?
Provide a succinct answer. -25.41. What is the ratio of the Education completion rate(%) of Fragile and conflict affected situations in 2000 to that in 2001?
Ensure brevity in your answer.  0.95. What is the ratio of the Education completion rate(%) in Sub-Saharan Africa (all income levels) in 2000 to that in 2001?
Your response must be concise. 0.96. What is the ratio of the Education completion rate(%) in Bhutan in 2000 to that in 2001?
Offer a terse response. 0.79. What is the ratio of the Education completion rate(%) in Fragile and conflict affected situations in 2000 to that in 2006?
Your answer should be compact. 0.84. What is the ratio of the Education completion rate(%) in Least developed countries in 2000 to that in 2006?
Ensure brevity in your answer.  0.85. What is the ratio of the Education completion rate(%) in Sub-Saharan Africa (all income levels) in 2000 to that in 2006?
Make the answer very short. 0.82. What is the ratio of the Education completion rate(%) of Bhutan in 2000 to that in 2006?
Your answer should be very brief. 0.61. What is the ratio of the Education completion rate(%) of Fragile and conflict affected situations in 2000 to that in 2008?
Give a very brief answer. 0.81. What is the ratio of the Education completion rate(%) in Least developed countries in 2000 to that in 2008?
Keep it short and to the point. 0.79. What is the ratio of the Education completion rate(%) of Sub-Saharan Africa (all income levels) in 2000 to that in 2008?
Your response must be concise. 0.75. What is the ratio of the Education completion rate(%) of Bhutan in 2000 to that in 2008?
Ensure brevity in your answer.  0.54. What is the ratio of the Education completion rate(%) in Fragile and conflict affected situations in 2000 to that in 2009?
Offer a terse response. 0.8. What is the ratio of the Education completion rate(%) of Least developed countries in 2000 to that in 2009?
Provide a succinct answer. 0.76. What is the ratio of the Education completion rate(%) in Sub-Saharan Africa (all income levels) in 2000 to that in 2009?
Your answer should be compact. 0.73. What is the ratio of the Education completion rate(%) of Bhutan in 2000 to that in 2009?
Provide a succinct answer. 0.49. What is the ratio of the Education completion rate(%) of Fragile and conflict affected situations in 2000 to that in 2010?
Your answer should be compact. 0.8. What is the ratio of the Education completion rate(%) of Least developed countries in 2000 to that in 2010?
Offer a very short reply. 0.75. What is the ratio of the Education completion rate(%) in Sub-Saharan Africa (all income levels) in 2000 to that in 2010?
Ensure brevity in your answer.  0.71. What is the ratio of the Education completion rate(%) in Bhutan in 2000 to that in 2010?
Your response must be concise. 0.41. What is the ratio of the Education completion rate(%) in Fragile and conflict affected situations in 2000 to that in 2011?
Give a very brief answer. 0.79. What is the ratio of the Education completion rate(%) of Least developed countries in 2000 to that in 2011?
Your answer should be compact. 0.73. What is the ratio of the Education completion rate(%) in Sub-Saharan Africa (all income levels) in 2000 to that in 2011?
Your answer should be very brief. 0.7. What is the ratio of the Education completion rate(%) of Bhutan in 2000 to that in 2011?
Make the answer very short. 0.42. What is the ratio of the Education completion rate(%) of Fragile and conflict affected situations in 2001 to that in 2006?
Offer a terse response. 0.88. What is the ratio of the Education completion rate(%) of Least developed countries in 2001 to that in 2006?
Offer a terse response. 0.87. What is the ratio of the Education completion rate(%) in Sub-Saharan Africa (all income levels) in 2001 to that in 2006?
Give a very brief answer. 0.86. What is the ratio of the Education completion rate(%) in Bhutan in 2001 to that in 2006?
Provide a succinct answer. 0.77. What is the ratio of the Education completion rate(%) of Fragile and conflict affected situations in 2001 to that in 2008?
Give a very brief answer. 0.85. What is the ratio of the Education completion rate(%) in Least developed countries in 2001 to that in 2008?
Provide a succinct answer. 0.81. What is the ratio of the Education completion rate(%) in Sub-Saharan Africa (all income levels) in 2001 to that in 2008?
Your answer should be compact. 0.78. What is the ratio of the Education completion rate(%) of Bhutan in 2001 to that in 2008?
Ensure brevity in your answer.  0.69. What is the ratio of the Education completion rate(%) in Fragile and conflict affected situations in 2001 to that in 2009?
Ensure brevity in your answer.  0.83. What is the ratio of the Education completion rate(%) of Least developed countries in 2001 to that in 2009?
Make the answer very short. 0.79. What is the ratio of the Education completion rate(%) of Sub-Saharan Africa (all income levels) in 2001 to that in 2009?
Offer a very short reply. 0.76. What is the ratio of the Education completion rate(%) of Bhutan in 2001 to that in 2009?
Make the answer very short. 0.62. What is the ratio of the Education completion rate(%) in Fragile and conflict affected situations in 2001 to that in 2010?
Give a very brief answer. 0.83. What is the ratio of the Education completion rate(%) of Least developed countries in 2001 to that in 2010?
Offer a terse response. 0.78. What is the ratio of the Education completion rate(%) in Sub-Saharan Africa (all income levels) in 2001 to that in 2010?
Ensure brevity in your answer.  0.74. What is the ratio of the Education completion rate(%) in Bhutan in 2001 to that in 2010?
Give a very brief answer. 0.52. What is the ratio of the Education completion rate(%) of Fragile and conflict affected situations in 2001 to that in 2011?
Give a very brief answer. 0.83. What is the ratio of the Education completion rate(%) of Least developed countries in 2001 to that in 2011?
Ensure brevity in your answer.  0.76. What is the ratio of the Education completion rate(%) in Sub-Saharan Africa (all income levels) in 2001 to that in 2011?
Offer a very short reply. 0.73. What is the ratio of the Education completion rate(%) of Bhutan in 2001 to that in 2011?
Provide a short and direct response. 0.53. What is the ratio of the Education completion rate(%) in Fragile and conflict affected situations in 2006 to that in 2008?
Offer a very short reply. 0.96. What is the ratio of the Education completion rate(%) of Least developed countries in 2006 to that in 2008?
Provide a succinct answer. 0.93. What is the ratio of the Education completion rate(%) of Sub-Saharan Africa (all income levels) in 2006 to that in 2008?
Keep it short and to the point. 0.91. What is the ratio of the Education completion rate(%) in Bhutan in 2006 to that in 2008?
Keep it short and to the point. 0.89. What is the ratio of the Education completion rate(%) of Fragile and conflict affected situations in 2006 to that in 2009?
Keep it short and to the point. 0.95. What is the ratio of the Education completion rate(%) of Least developed countries in 2006 to that in 2009?
Make the answer very short. 0.9. What is the ratio of the Education completion rate(%) of Sub-Saharan Africa (all income levels) in 2006 to that in 2009?
Give a very brief answer. 0.88. What is the ratio of the Education completion rate(%) of Bhutan in 2006 to that in 2009?
Make the answer very short. 0.8. What is the ratio of the Education completion rate(%) in Fragile and conflict affected situations in 2006 to that in 2010?
Provide a succinct answer. 0.95. What is the ratio of the Education completion rate(%) of Least developed countries in 2006 to that in 2010?
Keep it short and to the point. 0.89. What is the ratio of the Education completion rate(%) of Sub-Saharan Africa (all income levels) in 2006 to that in 2010?
Your answer should be compact. 0.87. What is the ratio of the Education completion rate(%) in Bhutan in 2006 to that in 2010?
Ensure brevity in your answer.  0.67. What is the ratio of the Education completion rate(%) of Fragile and conflict affected situations in 2006 to that in 2011?
Provide a short and direct response. 0.94. What is the ratio of the Education completion rate(%) of Least developed countries in 2006 to that in 2011?
Ensure brevity in your answer.  0.86. What is the ratio of the Education completion rate(%) in Sub-Saharan Africa (all income levels) in 2006 to that in 2011?
Your response must be concise. 0.85. What is the ratio of the Education completion rate(%) of Bhutan in 2006 to that in 2011?
Offer a terse response. 0.69. What is the ratio of the Education completion rate(%) of Fragile and conflict affected situations in 2008 to that in 2009?
Offer a terse response. 0.98. What is the ratio of the Education completion rate(%) of Least developed countries in 2008 to that in 2009?
Give a very brief answer. 0.97. What is the ratio of the Education completion rate(%) of Sub-Saharan Africa (all income levels) in 2008 to that in 2009?
Your response must be concise. 0.97. What is the ratio of the Education completion rate(%) in Bhutan in 2008 to that in 2009?
Keep it short and to the point. 0.89. What is the ratio of the Education completion rate(%) in Fragile and conflict affected situations in 2008 to that in 2010?
Provide a short and direct response. 0.98. What is the ratio of the Education completion rate(%) of Least developed countries in 2008 to that in 2010?
Provide a short and direct response. 0.96. What is the ratio of the Education completion rate(%) of Sub-Saharan Africa (all income levels) in 2008 to that in 2010?
Offer a very short reply. 0.95. What is the ratio of the Education completion rate(%) in Bhutan in 2008 to that in 2010?
Give a very brief answer. 0.75. What is the ratio of the Education completion rate(%) in Fragile and conflict affected situations in 2008 to that in 2011?
Offer a very short reply. 0.98. What is the ratio of the Education completion rate(%) of Least developed countries in 2008 to that in 2011?
Offer a terse response. 0.93. What is the ratio of the Education completion rate(%) of Sub-Saharan Africa (all income levels) in 2008 to that in 2011?
Your answer should be compact. 0.93. What is the ratio of the Education completion rate(%) of Bhutan in 2008 to that in 2011?
Ensure brevity in your answer.  0.77. What is the ratio of the Education completion rate(%) in Fragile and conflict affected situations in 2009 to that in 2010?
Your response must be concise. 1. What is the ratio of the Education completion rate(%) of Least developed countries in 2009 to that in 2010?
Provide a succinct answer. 0.99. What is the ratio of the Education completion rate(%) in Sub-Saharan Africa (all income levels) in 2009 to that in 2010?
Make the answer very short. 0.98. What is the ratio of the Education completion rate(%) in Bhutan in 2009 to that in 2010?
Make the answer very short. 0.84. What is the ratio of the Education completion rate(%) of Fragile and conflict affected situations in 2009 to that in 2011?
Give a very brief answer. 1. What is the ratio of the Education completion rate(%) of Least developed countries in 2009 to that in 2011?
Offer a terse response. 0.96. What is the ratio of the Education completion rate(%) of Bhutan in 2009 to that in 2011?
Provide a short and direct response. 0.87. What is the ratio of the Education completion rate(%) in Least developed countries in 2010 to that in 2011?
Make the answer very short. 0.97. What is the ratio of the Education completion rate(%) of Sub-Saharan Africa (all income levels) in 2010 to that in 2011?
Offer a terse response. 0.98. What is the ratio of the Education completion rate(%) in Bhutan in 2010 to that in 2011?
Your answer should be very brief. 1.03. What is the difference between the highest and the second highest Education completion rate(%) in Fragile and conflict affected situations?
Keep it short and to the point. 0.17. What is the difference between the highest and the second highest Education completion rate(%) in Least developed countries?
Your response must be concise. 1.09. What is the difference between the highest and the second highest Education completion rate(%) of Sub-Saharan Africa (all income levels)?
Your response must be concise. 0.8. What is the difference between the highest and the second highest Education completion rate(%) of Bhutan?
Offer a very short reply. 2.01. What is the difference between the highest and the lowest Education completion rate(%) in Fragile and conflict affected situations?
Your answer should be very brief. 9.5. What is the difference between the highest and the lowest Education completion rate(%) of Least developed countries?
Your answer should be compact. 11.04. What is the difference between the highest and the lowest Education completion rate(%) in Sub-Saharan Africa (all income levels)?
Your answer should be compact. 12.42. What is the difference between the highest and the lowest Education completion rate(%) in Bhutan?
Your answer should be compact. 40.52. 